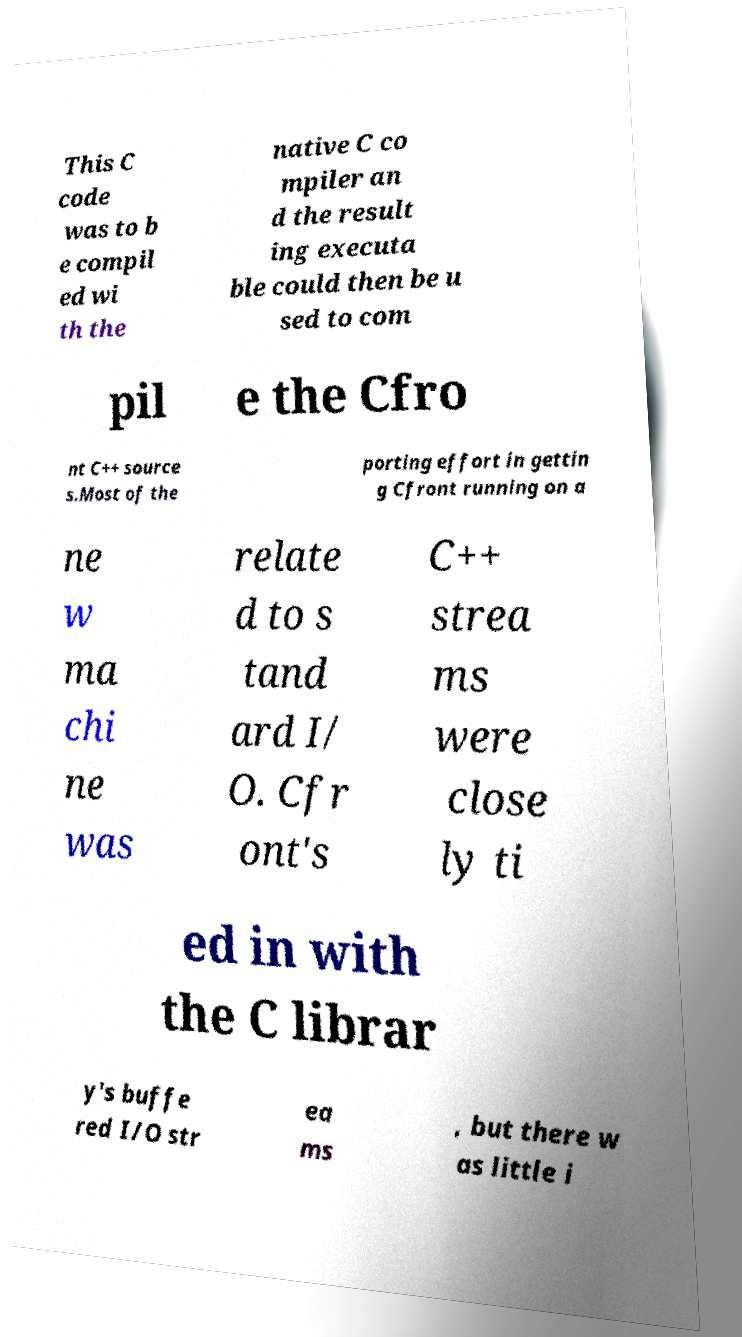Could you extract and type out the text from this image? This C code was to b e compil ed wi th the native C co mpiler an d the result ing executa ble could then be u sed to com pil e the Cfro nt C++ source s.Most of the porting effort in gettin g Cfront running on a ne w ma chi ne was relate d to s tand ard I/ O. Cfr ont's C++ strea ms were close ly ti ed in with the C librar y's buffe red I/O str ea ms , but there w as little i 